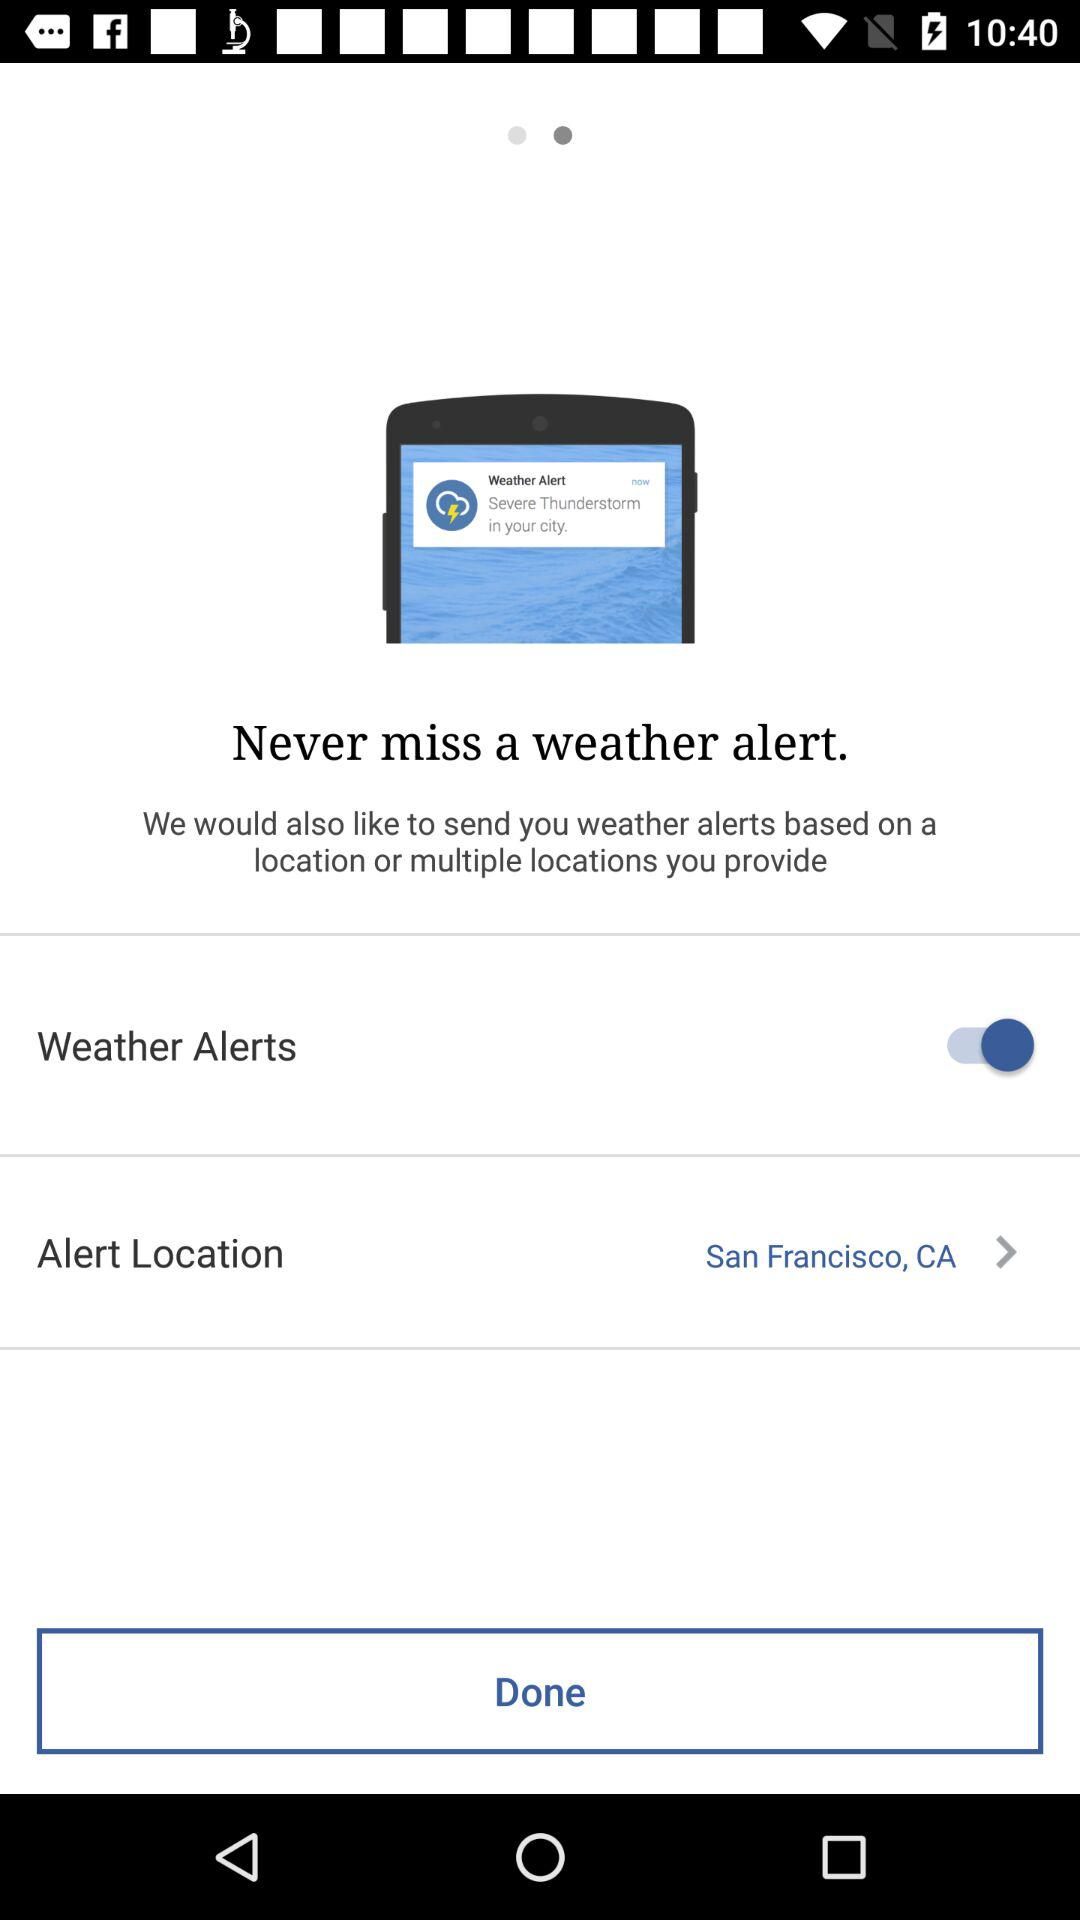What is the status of the "Weather Alters"? The status is "on". 